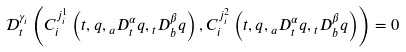Convert formula to latex. <formula><loc_0><loc_0><loc_500><loc_500>\mathcal { D } _ { t } ^ { \gamma _ { i } } \left ( C _ { i } ^ { j _ { i } ^ { 1 } } \left ( t , q , { _ { a } D _ { t } ^ { \alpha } q } , { _ { t } D _ { b } ^ { \beta } q } \right ) , C _ { i } ^ { j _ { i } ^ { 2 } } \left ( t , q , { _ { a } D _ { t } ^ { \alpha } q } , { _ { t } D _ { b } ^ { \beta } q } \right ) \right ) = 0</formula> 